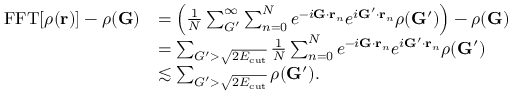Convert formula to latex. <formula><loc_0><loc_0><loc_500><loc_500>\begin{array} { r l } { F F T [ \rho ( r ) ] - \rho ( G ) } & { = \left ( \frac { 1 } { N } \sum _ { G ^ { \prime } } ^ { \infty } \sum _ { n = 0 } ^ { N } e ^ { - i G \cdot r _ { n } } e ^ { i G ^ { \prime } \cdot r _ { n } } \rho ( G ^ { \prime } ) \right ) - \rho ( G ) } \\ & { = \sum _ { G ^ { \prime } > \sqrt { 2 E _ { c u t } } } \frac { 1 } { N } \sum _ { n = 0 } ^ { N } e ^ { - i G \cdot r _ { n } } e ^ { i G ^ { \prime } \cdot r _ { n } } \rho ( G ^ { \prime } ) } \\ & { \lesssim \sum _ { G ^ { \prime } > \sqrt { 2 E _ { c u t } } } \rho ( G ^ { \prime } ) . } \end{array}</formula> 